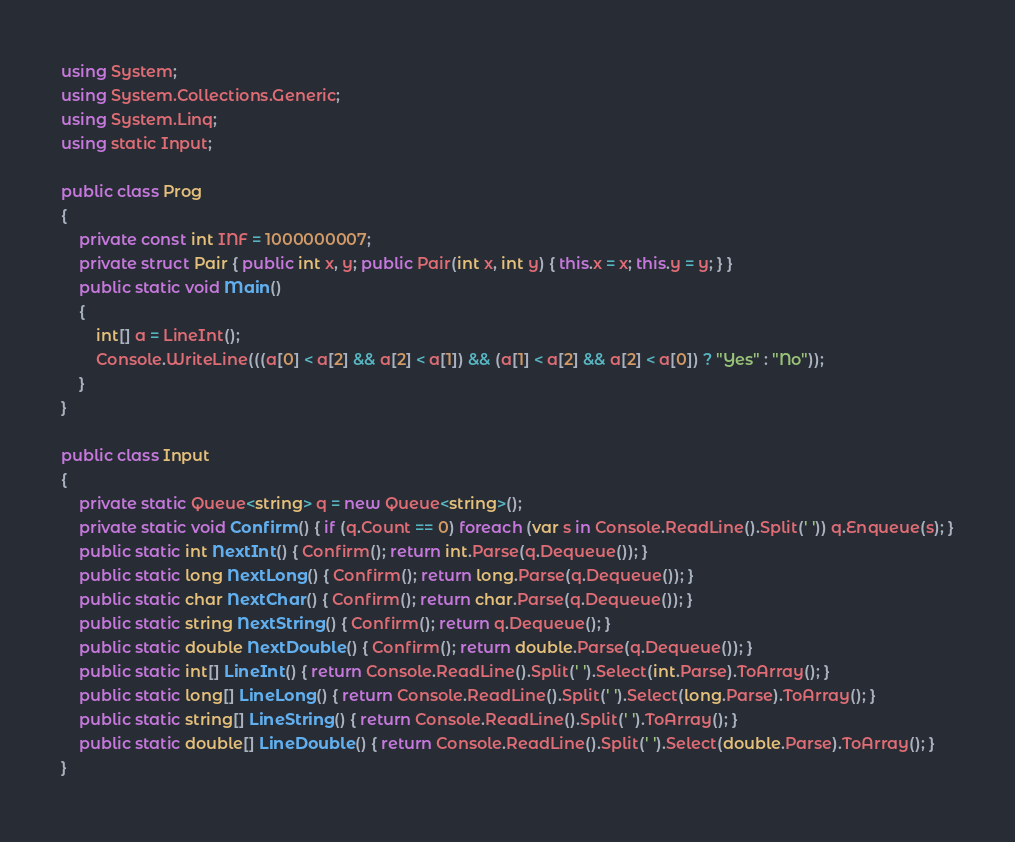<code> <loc_0><loc_0><loc_500><loc_500><_C#_>using System;
using System.Collections.Generic;
using System.Linq;
using static Input;

public class Prog
{
    private const int INF = 1000000007;
    private struct Pair { public int x, y; public Pair(int x, int y) { this.x = x; this.y = y; } }
    public static void Main()
    {
        int[] a = LineInt();
        Console.WriteLine(((a[0] < a[2] && a[2] < a[1]) && (a[1] < a[2] && a[2] < a[0]) ? "Yes" : "No"));
    }
}

public class Input
{
    private static Queue<string> q = new Queue<string>();
    private static void Confirm() { if (q.Count == 0) foreach (var s in Console.ReadLine().Split(' ')) q.Enqueue(s); }
    public static int NextInt() { Confirm(); return int.Parse(q.Dequeue()); }
    public static long NextLong() { Confirm(); return long.Parse(q.Dequeue()); }
    public static char NextChar() { Confirm(); return char.Parse(q.Dequeue()); }
    public static string NextString() { Confirm(); return q.Dequeue(); }
    public static double NextDouble() { Confirm(); return double.Parse(q.Dequeue()); }
    public static int[] LineInt() { return Console.ReadLine().Split(' ').Select(int.Parse).ToArray(); }
    public static long[] LineLong() { return Console.ReadLine().Split(' ').Select(long.Parse).ToArray(); }
    public static string[] LineString() { return Console.ReadLine().Split(' ').ToArray(); }
    public static double[] LineDouble() { return Console.ReadLine().Split(' ').Select(double.Parse).ToArray(); }
}
</code> 